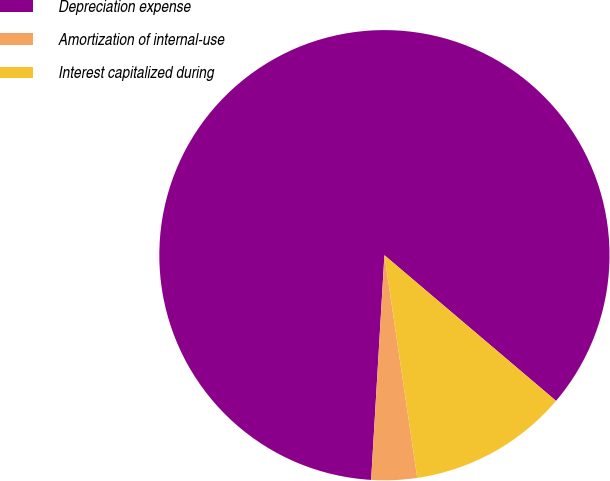Convert chart to OTSL. <chart><loc_0><loc_0><loc_500><loc_500><pie_chart><fcel>Depreciation expense<fcel>Amortization of internal-use<fcel>Interest capitalized during<nl><fcel>85.26%<fcel>3.27%<fcel>11.47%<nl></chart> 